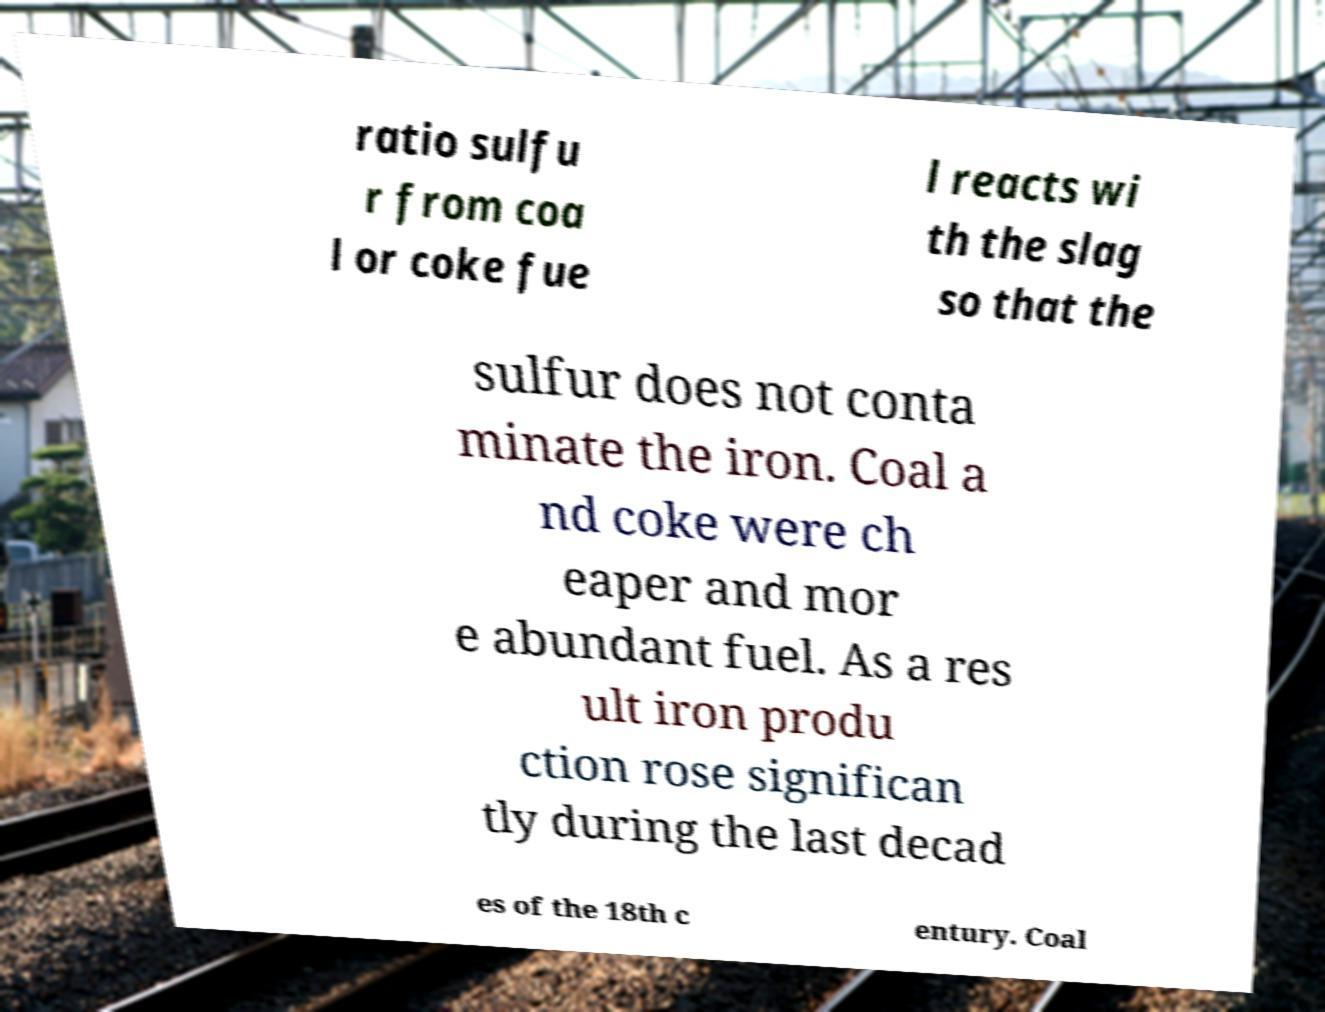Could you assist in decoding the text presented in this image and type it out clearly? ratio sulfu r from coa l or coke fue l reacts wi th the slag so that the sulfur does not conta minate the iron. Coal a nd coke were ch eaper and mor e abundant fuel. As a res ult iron produ ction rose significan tly during the last decad es of the 18th c entury. Coal 